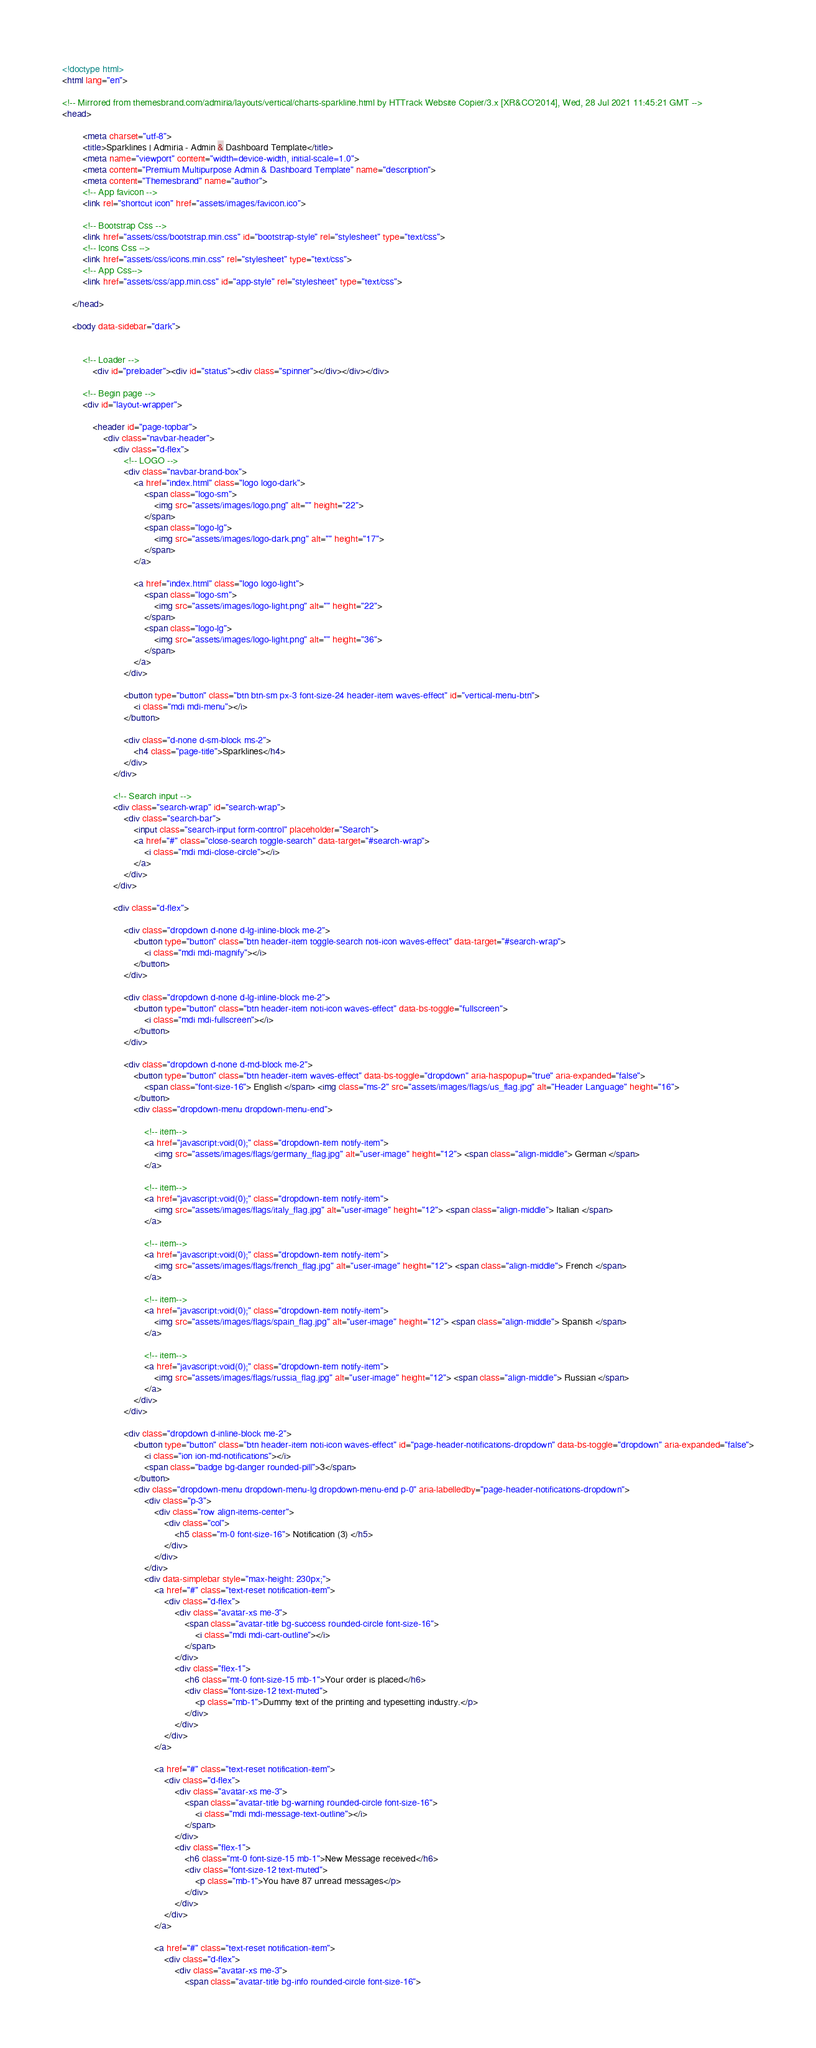Convert code to text. <code><loc_0><loc_0><loc_500><loc_500><_HTML_><!doctype html>
<html lang="en">
    
<!-- Mirrored from themesbrand.com/admiria/layouts/vertical/charts-sparkline.html by HTTrack Website Copier/3.x [XR&CO'2014], Wed, 28 Jul 2021 11:45:21 GMT -->
<head>

        <meta charset="utf-8">
        <title>Sparklines | Admiria - Admin & Dashboard Template</title>
        <meta name="viewport" content="width=device-width, initial-scale=1.0">
        <meta content="Premium Multipurpose Admin & Dashboard Template" name="description">
        <meta content="Themesbrand" name="author">
        <!-- App favicon -->
        <link rel="shortcut icon" href="assets/images/favicon.ico">
    
        <!-- Bootstrap Css -->
        <link href="assets/css/bootstrap.min.css" id="bootstrap-style" rel="stylesheet" type="text/css">
        <!-- Icons Css -->
        <link href="assets/css/icons.min.css" rel="stylesheet" type="text/css">
        <!-- App Css-->
        <link href="assets/css/app.min.css" id="app-style" rel="stylesheet" type="text/css">
    
    </head>

    <body data-sidebar="dark">


        <!-- Loader -->
            <div id="preloader"><div id="status"><div class="spinner"></div></div></div>

        <!-- Begin page -->
        <div id="layout-wrapper">

            <header id="page-topbar">
                <div class="navbar-header">
                    <div class="d-flex">
                        <!-- LOGO -->
                        <div class="navbar-brand-box">
                            <a href="index.html" class="logo logo-dark">
                                <span class="logo-sm">
                                    <img src="assets/images/logo.png" alt="" height="22">
                                </span>
                                <span class="logo-lg">
                                    <img src="assets/images/logo-dark.png" alt="" height="17">
                                </span>
                            </a>

                            <a href="index.html" class="logo logo-light">
                                <span class="logo-sm">
                                    <img src="assets/images/logo-light.png" alt="" height="22">
                                </span>
                                <span class="logo-lg">
                                    <img src="assets/images/logo-light.png" alt="" height="36">
                                </span>
                            </a>
                        </div>

                        <button type="button" class="btn btn-sm px-3 font-size-24 header-item waves-effect" id="vertical-menu-btn">
                            <i class="mdi mdi-menu"></i>
                        </button>

                        <div class="d-none d-sm-block ms-2">
                            <h4 class="page-title">Sparklines</h4>
                        </div>
                    </div>

                    <!-- Search input -->
                    <div class="search-wrap" id="search-wrap">
                        <div class="search-bar">
                            <input class="search-input form-control" placeholder="Search">
                            <a href="#" class="close-search toggle-search" data-target="#search-wrap">
                                <i class="mdi mdi-close-circle"></i>
                            </a>
                        </div>
                    </div>

                    <div class="d-flex">

                        <div class="dropdown d-none d-lg-inline-block me-2">
                            <button type="button" class="btn header-item toggle-search noti-icon waves-effect" data-target="#search-wrap">
                                <i class="mdi mdi-magnify"></i>
                            </button>
                        </div>

                        <div class="dropdown d-none d-lg-inline-block me-2">
                            <button type="button" class="btn header-item noti-icon waves-effect" data-bs-toggle="fullscreen">
                                <i class="mdi mdi-fullscreen"></i>
                            </button>
                        </div>

                        <div class="dropdown d-none d-md-block me-2">
                            <button type="button" class="btn header-item waves-effect" data-bs-toggle="dropdown" aria-haspopup="true" aria-expanded="false">
                                <span class="font-size-16"> English </span> <img class="ms-2" src="assets/images/flags/us_flag.jpg" alt="Header Language" height="16">
                            </button>
                            <div class="dropdown-menu dropdown-menu-end">

                                <!-- item-->
                                <a href="javascript:void(0);" class="dropdown-item notify-item">
                                    <img src="assets/images/flags/germany_flag.jpg" alt="user-image" height="12"> <span class="align-middle"> German </span>
                                </a>

                                <!-- item-->
                                <a href="javascript:void(0);" class="dropdown-item notify-item">
                                    <img src="assets/images/flags/italy_flag.jpg" alt="user-image" height="12"> <span class="align-middle"> Italian </span>
                                </a>

                                <!-- item-->
                                <a href="javascript:void(0);" class="dropdown-item notify-item">
                                    <img src="assets/images/flags/french_flag.jpg" alt="user-image" height="12"> <span class="align-middle"> French </span>
                                </a>

                                <!-- item-->
                                <a href="javascript:void(0);" class="dropdown-item notify-item">
                                    <img src="assets/images/flags/spain_flag.jpg" alt="user-image" height="12"> <span class="align-middle"> Spanish </span>
                                </a>

                                <!-- item-->
                                <a href="javascript:void(0);" class="dropdown-item notify-item">
                                    <img src="assets/images/flags/russia_flag.jpg" alt="user-image" height="12"> <span class="align-middle"> Russian </span>
                                </a>
                            </div>
                        </div>

                        <div class="dropdown d-inline-block me-2">
                            <button type="button" class="btn header-item noti-icon waves-effect" id="page-header-notifications-dropdown" data-bs-toggle="dropdown" aria-expanded="false">
                                <i class="ion ion-md-notifications"></i>
                                <span class="badge bg-danger rounded-pill">3</span>
                            </button>
                            <div class="dropdown-menu dropdown-menu-lg dropdown-menu-end p-0" aria-labelledby="page-header-notifications-dropdown">
                                <div class="p-3">
                                    <div class="row align-items-center">
                                        <div class="col">
                                            <h5 class="m-0 font-size-16"> Notification (3) </h5>
                                        </div>
                                    </div>
                                </div>
                                <div data-simplebar style="max-height: 230px;">
                                    <a href="#" class="text-reset notification-item">
                                        <div class="d-flex">
                                            <div class="avatar-xs me-3">
                                                <span class="avatar-title bg-success rounded-circle font-size-16">
                                                    <i class="mdi mdi-cart-outline"></i>
                                                </span>
                                            </div>
                                            <div class="flex-1">
                                                <h6 class="mt-0 font-size-15 mb-1">Your order is placed</h6>
                                                <div class="font-size-12 text-muted">
                                                    <p class="mb-1">Dummy text of the printing and typesetting industry.</p>
                                                </div>
                                            </div>
                                        </div>
                                    </a>

                                    <a href="#" class="text-reset notification-item">
                                        <div class="d-flex">
                                            <div class="avatar-xs me-3">
                                                <span class="avatar-title bg-warning rounded-circle font-size-16">
                                                    <i class="mdi mdi-message-text-outline"></i>
                                                </span>
                                            </div>
                                            <div class="flex-1">
                                                <h6 class="mt-0 font-size-15 mb-1">New Message received</h6>
                                                <div class="font-size-12 text-muted">
                                                    <p class="mb-1">You have 87 unread messages</p>
                                                </div>
                                            </div>
                                        </div>
                                    </a>

                                    <a href="#" class="text-reset notification-item">
                                        <div class="d-flex">
                                            <div class="avatar-xs me-3">
                                                <span class="avatar-title bg-info rounded-circle font-size-16"></code> 